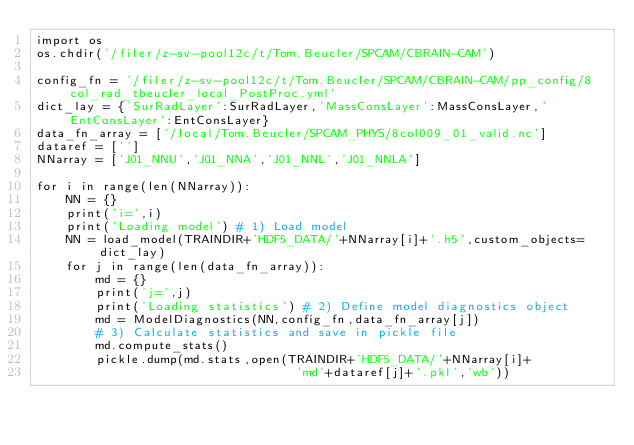<code> <loc_0><loc_0><loc_500><loc_500><_Python_>import os
os.chdir('/filer/z-sv-pool12c/t/Tom.Beucler/SPCAM/CBRAIN-CAM')

config_fn = '/filer/z-sv-pool12c/t/Tom.Beucler/SPCAM/CBRAIN-CAM/pp_config/8col_rad_tbeucler_local_PostProc.yml'
dict_lay = {'SurRadLayer':SurRadLayer,'MassConsLayer':MassConsLayer,'EntConsLayer':EntConsLayer}
data_fn_array = ['/local/Tom.Beucler/SPCAM_PHYS/8col009_01_valid.nc']
dataref = ['']
NNarray = ['J01_NNU','J01_NNA','J01_NNL','J01_NNLA']

for i in range(len(NNarray)):
    NN = {}
    print('i=',i)
    print('Loading model') # 1) Load model
    NN = load_model(TRAINDIR+'HDF5_DATA/'+NNarray[i]+'.h5',custom_objects=dict_lay)    
    for j in range(len(data_fn_array)):
        md = {}
        print('j=',j)
        print('Loading statistics') # 2) Define model diagnostics object
        md = ModelDiagnostics(NN,config_fn,data_fn_array[j])
        # 3) Calculate statistics and save in pickle file
        md.compute_stats()
        pickle.dump(md.stats,open(TRAINDIR+'HDF5_DATA/'+NNarray[i]+
                                   'md'+dataref[j]+'.pkl','wb'))</code> 